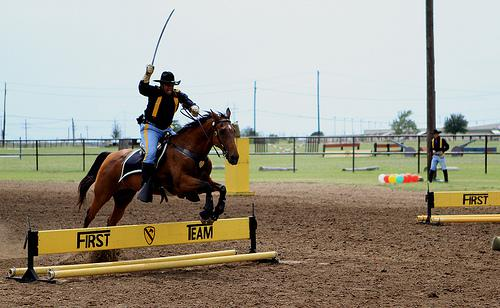Question: who is the man?
Choices:
A. Rider.
B. Conductor.
C. Physician.
D. Teacher.
Answer with the letter. Answer: A Question: when was the photo taken?
Choices:
A. In the fall.
B. In the evening.
C. Morning.
D. In the winter.
Answer with the letter. Answer: C Question: where is the photo?
Choices:
A. Mountain.
B. Field.
C. Movie theater.
D. A gymnasium.
Answer with the letter. Answer: B 